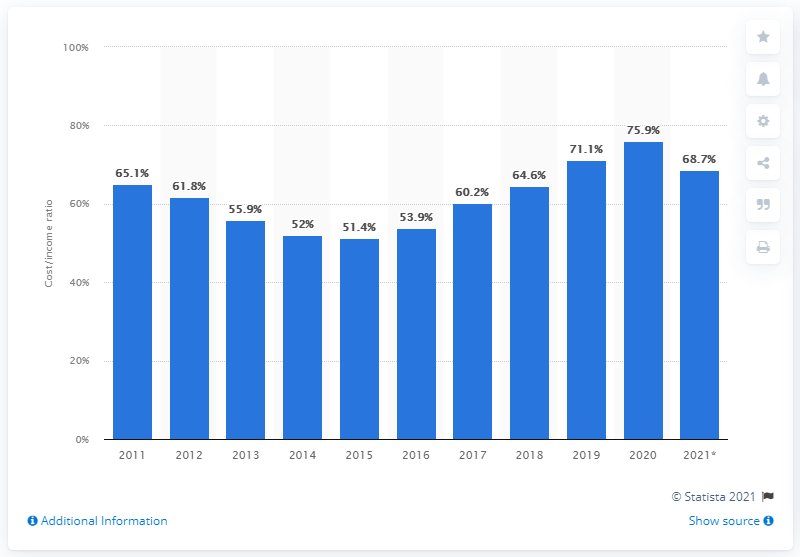Highlight a few significant elements in this photo. In 2020, the cost to income ratio for Nationwide Building Society was 75.9%. The cost to income ratio in the first half of the 2021 financial year was 68.7%. 